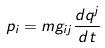<formula> <loc_0><loc_0><loc_500><loc_500>p _ { i } = m g _ { i j } \frac { d q ^ { j } } { d t }</formula> 